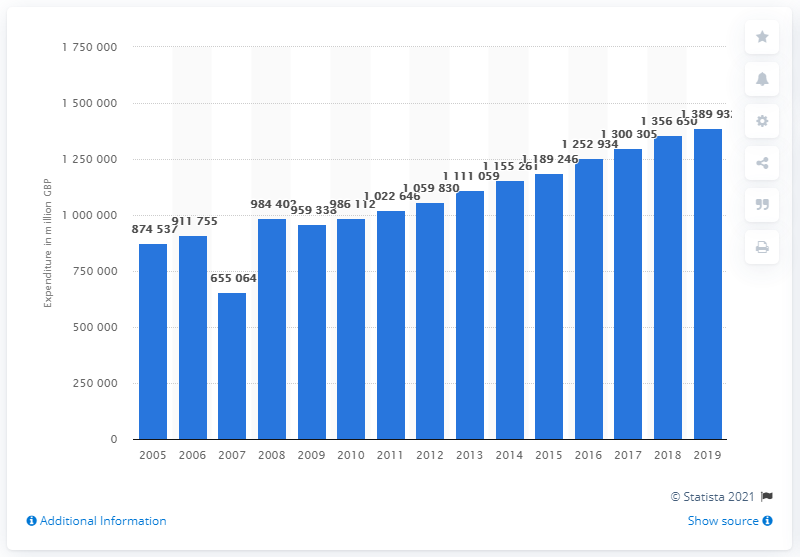Identify some key points in this picture. The total domestic consumption expenditure in the UK from 2005 to 2019 was 138,993,200. 